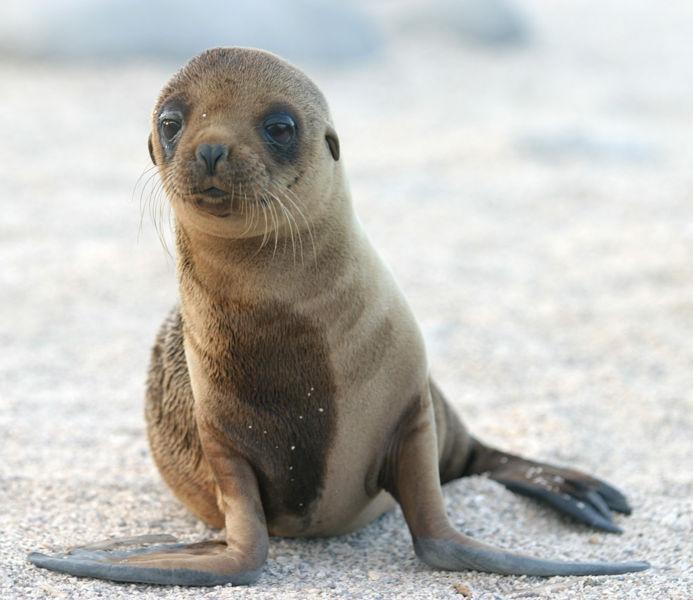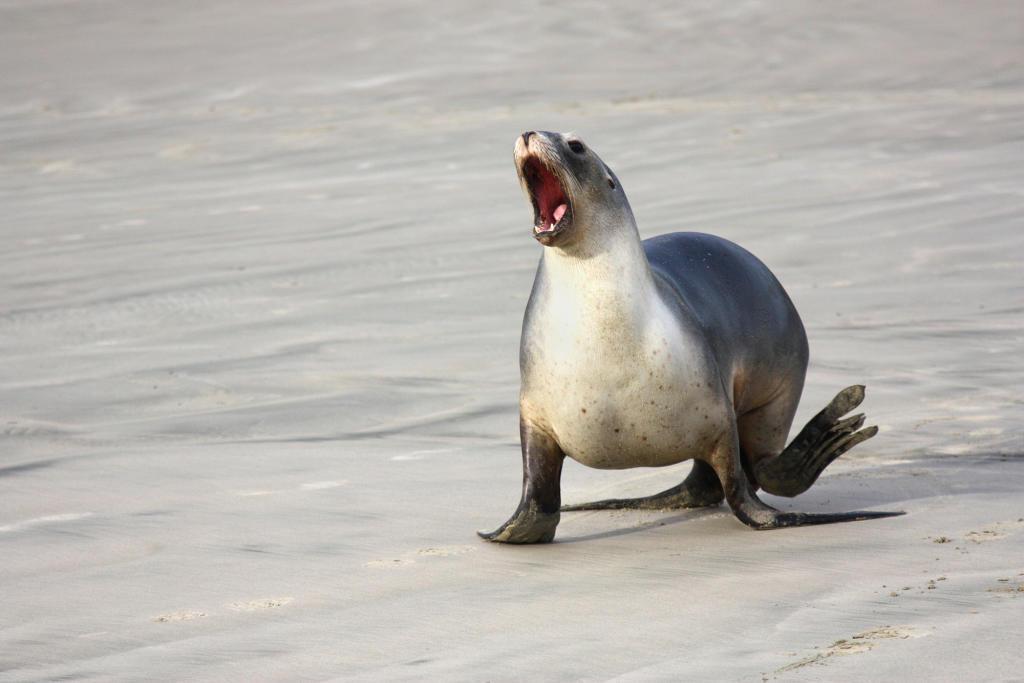The first image is the image on the left, the second image is the image on the right. For the images shown, is this caption "The left image depicts a young seal which is not black." true? Answer yes or no. Yes. 